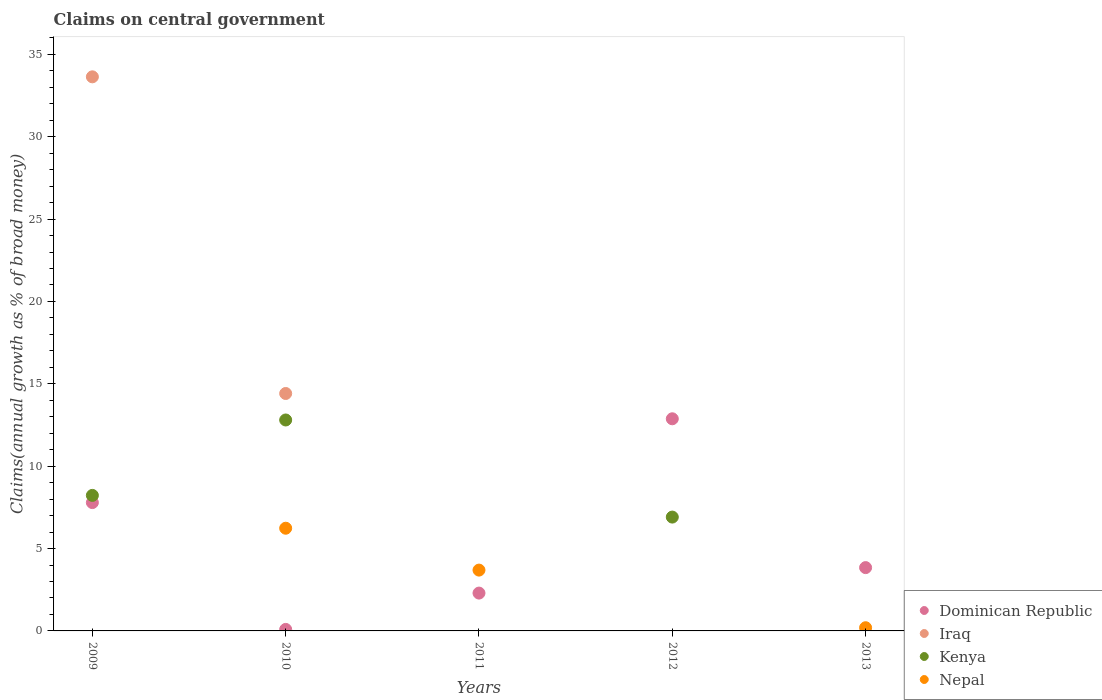Is the number of dotlines equal to the number of legend labels?
Your answer should be very brief. No. What is the percentage of broad money claimed on centeral government in Dominican Republic in 2013?
Provide a short and direct response. 3.84. Across all years, what is the maximum percentage of broad money claimed on centeral government in Iraq?
Provide a succinct answer. 33.64. Across all years, what is the minimum percentage of broad money claimed on centeral government in Nepal?
Provide a succinct answer. 0. In which year was the percentage of broad money claimed on centeral government in Dominican Republic maximum?
Make the answer very short. 2012. What is the total percentage of broad money claimed on centeral government in Nepal in the graph?
Provide a succinct answer. 10.12. What is the difference between the percentage of broad money claimed on centeral government in Iraq in 2009 and that in 2010?
Make the answer very short. 19.22. What is the difference between the percentage of broad money claimed on centeral government in Kenya in 2011 and the percentage of broad money claimed on centeral government in Dominican Republic in 2009?
Your answer should be very brief. -7.79. What is the average percentage of broad money claimed on centeral government in Iraq per year?
Your answer should be very brief. 9.61. In the year 2009, what is the difference between the percentage of broad money claimed on centeral government in Iraq and percentage of broad money claimed on centeral government in Dominican Republic?
Your answer should be very brief. 25.85. What is the ratio of the percentage of broad money claimed on centeral government in Dominican Republic in 2012 to that in 2013?
Give a very brief answer. 3.35. What is the difference between the highest and the second highest percentage of broad money claimed on centeral government in Kenya?
Give a very brief answer. 4.58. What is the difference between the highest and the lowest percentage of broad money claimed on centeral government in Kenya?
Give a very brief answer. 12.81. In how many years, is the percentage of broad money claimed on centeral government in Kenya greater than the average percentage of broad money claimed on centeral government in Kenya taken over all years?
Provide a succinct answer. 3. Is the sum of the percentage of broad money claimed on centeral government in Nepal in 2010 and 2011 greater than the maximum percentage of broad money claimed on centeral government in Kenya across all years?
Provide a succinct answer. No. Does the percentage of broad money claimed on centeral government in Nepal monotonically increase over the years?
Ensure brevity in your answer.  No. Is the percentage of broad money claimed on centeral government in Dominican Republic strictly greater than the percentage of broad money claimed on centeral government in Nepal over the years?
Offer a very short reply. No. What is the difference between two consecutive major ticks on the Y-axis?
Give a very brief answer. 5. Are the values on the major ticks of Y-axis written in scientific E-notation?
Ensure brevity in your answer.  No. Does the graph contain any zero values?
Keep it short and to the point. Yes. Does the graph contain grids?
Keep it short and to the point. No. How are the legend labels stacked?
Your answer should be compact. Vertical. What is the title of the graph?
Offer a terse response. Claims on central government. What is the label or title of the Y-axis?
Provide a succinct answer. Claims(annual growth as % of broad money). What is the Claims(annual growth as % of broad money) in Dominican Republic in 2009?
Make the answer very short. 7.79. What is the Claims(annual growth as % of broad money) in Iraq in 2009?
Ensure brevity in your answer.  33.64. What is the Claims(annual growth as % of broad money) in Kenya in 2009?
Ensure brevity in your answer.  8.23. What is the Claims(annual growth as % of broad money) of Dominican Republic in 2010?
Offer a very short reply. 0.09. What is the Claims(annual growth as % of broad money) in Iraq in 2010?
Keep it short and to the point. 14.41. What is the Claims(annual growth as % of broad money) of Kenya in 2010?
Make the answer very short. 12.81. What is the Claims(annual growth as % of broad money) in Nepal in 2010?
Offer a terse response. 6.23. What is the Claims(annual growth as % of broad money) in Dominican Republic in 2011?
Make the answer very short. 2.3. What is the Claims(annual growth as % of broad money) of Kenya in 2011?
Keep it short and to the point. 0. What is the Claims(annual growth as % of broad money) in Nepal in 2011?
Provide a succinct answer. 3.69. What is the Claims(annual growth as % of broad money) of Dominican Republic in 2012?
Your response must be concise. 12.88. What is the Claims(annual growth as % of broad money) of Iraq in 2012?
Your answer should be compact. 0. What is the Claims(annual growth as % of broad money) of Kenya in 2012?
Offer a terse response. 6.91. What is the Claims(annual growth as % of broad money) of Nepal in 2012?
Your answer should be compact. 0. What is the Claims(annual growth as % of broad money) of Dominican Republic in 2013?
Keep it short and to the point. 3.84. What is the Claims(annual growth as % of broad money) of Iraq in 2013?
Provide a succinct answer. 0. What is the Claims(annual growth as % of broad money) of Kenya in 2013?
Make the answer very short. 0. What is the Claims(annual growth as % of broad money) in Nepal in 2013?
Provide a short and direct response. 0.19. Across all years, what is the maximum Claims(annual growth as % of broad money) in Dominican Republic?
Your response must be concise. 12.88. Across all years, what is the maximum Claims(annual growth as % of broad money) of Iraq?
Ensure brevity in your answer.  33.64. Across all years, what is the maximum Claims(annual growth as % of broad money) in Kenya?
Give a very brief answer. 12.81. Across all years, what is the maximum Claims(annual growth as % of broad money) of Nepal?
Provide a short and direct response. 6.23. Across all years, what is the minimum Claims(annual growth as % of broad money) in Dominican Republic?
Give a very brief answer. 0.09. Across all years, what is the minimum Claims(annual growth as % of broad money) in Iraq?
Make the answer very short. 0. Across all years, what is the minimum Claims(annual growth as % of broad money) in Kenya?
Your answer should be compact. 0. Across all years, what is the minimum Claims(annual growth as % of broad money) in Nepal?
Your answer should be very brief. 0. What is the total Claims(annual growth as % of broad money) in Dominican Republic in the graph?
Your response must be concise. 26.9. What is the total Claims(annual growth as % of broad money) in Iraq in the graph?
Provide a succinct answer. 48.05. What is the total Claims(annual growth as % of broad money) in Kenya in the graph?
Your answer should be very brief. 27.94. What is the total Claims(annual growth as % of broad money) in Nepal in the graph?
Your answer should be compact. 10.12. What is the difference between the Claims(annual growth as % of broad money) in Dominican Republic in 2009 and that in 2010?
Offer a terse response. 7.7. What is the difference between the Claims(annual growth as % of broad money) in Iraq in 2009 and that in 2010?
Give a very brief answer. 19.22. What is the difference between the Claims(annual growth as % of broad money) of Kenya in 2009 and that in 2010?
Your answer should be very brief. -4.58. What is the difference between the Claims(annual growth as % of broad money) of Dominican Republic in 2009 and that in 2011?
Give a very brief answer. 5.49. What is the difference between the Claims(annual growth as % of broad money) in Dominican Republic in 2009 and that in 2012?
Your answer should be compact. -5.09. What is the difference between the Claims(annual growth as % of broad money) of Kenya in 2009 and that in 2012?
Make the answer very short. 1.32. What is the difference between the Claims(annual growth as % of broad money) of Dominican Republic in 2009 and that in 2013?
Offer a terse response. 3.95. What is the difference between the Claims(annual growth as % of broad money) in Dominican Republic in 2010 and that in 2011?
Make the answer very short. -2.21. What is the difference between the Claims(annual growth as % of broad money) in Nepal in 2010 and that in 2011?
Your answer should be compact. 2.54. What is the difference between the Claims(annual growth as % of broad money) in Dominican Republic in 2010 and that in 2012?
Give a very brief answer. -12.79. What is the difference between the Claims(annual growth as % of broad money) in Kenya in 2010 and that in 2012?
Offer a terse response. 5.9. What is the difference between the Claims(annual growth as % of broad money) in Dominican Republic in 2010 and that in 2013?
Your answer should be compact. -3.75. What is the difference between the Claims(annual growth as % of broad money) of Nepal in 2010 and that in 2013?
Your response must be concise. 6.04. What is the difference between the Claims(annual growth as % of broad money) in Dominican Republic in 2011 and that in 2012?
Offer a very short reply. -10.58. What is the difference between the Claims(annual growth as % of broad money) in Dominican Republic in 2011 and that in 2013?
Provide a succinct answer. -1.55. What is the difference between the Claims(annual growth as % of broad money) in Nepal in 2011 and that in 2013?
Ensure brevity in your answer.  3.5. What is the difference between the Claims(annual growth as % of broad money) in Dominican Republic in 2012 and that in 2013?
Offer a very short reply. 9.04. What is the difference between the Claims(annual growth as % of broad money) of Dominican Republic in 2009 and the Claims(annual growth as % of broad money) of Iraq in 2010?
Provide a succinct answer. -6.62. What is the difference between the Claims(annual growth as % of broad money) of Dominican Republic in 2009 and the Claims(annual growth as % of broad money) of Kenya in 2010?
Offer a terse response. -5.01. What is the difference between the Claims(annual growth as % of broad money) in Dominican Republic in 2009 and the Claims(annual growth as % of broad money) in Nepal in 2010?
Your answer should be compact. 1.56. What is the difference between the Claims(annual growth as % of broad money) of Iraq in 2009 and the Claims(annual growth as % of broad money) of Kenya in 2010?
Give a very brief answer. 20.83. What is the difference between the Claims(annual growth as % of broad money) of Iraq in 2009 and the Claims(annual growth as % of broad money) of Nepal in 2010?
Provide a short and direct response. 27.4. What is the difference between the Claims(annual growth as % of broad money) of Kenya in 2009 and the Claims(annual growth as % of broad money) of Nepal in 2010?
Your answer should be very brief. 1.99. What is the difference between the Claims(annual growth as % of broad money) of Dominican Republic in 2009 and the Claims(annual growth as % of broad money) of Nepal in 2011?
Provide a succinct answer. 4.1. What is the difference between the Claims(annual growth as % of broad money) of Iraq in 2009 and the Claims(annual growth as % of broad money) of Nepal in 2011?
Your answer should be very brief. 29.94. What is the difference between the Claims(annual growth as % of broad money) of Kenya in 2009 and the Claims(annual growth as % of broad money) of Nepal in 2011?
Your answer should be compact. 4.53. What is the difference between the Claims(annual growth as % of broad money) of Dominican Republic in 2009 and the Claims(annual growth as % of broad money) of Kenya in 2012?
Make the answer very short. 0.88. What is the difference between the Claims(annual growth as % of broad money) in Iraq in 2009 and the Claims(annual growth as % of broad money) in Kenya in 2012?
Provide a succinct answer. 26.73. What is the difference between the Claims(annual growth as % of broad money) in Dominican Republic in 2009 and the Claims(annual growth as % of broad money) in Nepal in 2013?
Provide a short and direct response. 7.6. What is the difference between the Claims(annual growth as % of broad money) in Iraq in 2009 and the Claims(annual growth as % of broad money) in Nepal in 2013?
Your answer should be very brief. 33.44. What is the difference between the Claims(annual growth as % of broad money) of Kenya in 2009 and the Claims(annual growth as % of broad money) of Nepal in 2013?
Your response must be concise. 8.03. What is the difference between the Claims(annual growth as % of broad money) in Dominican Republic in 2010 and the Claims(annual growth as % of broad money) in Nepal in 2011?
Your answer should be compact. -3.6. What is the difference between the Claims(annual growth as % of broad money) of Iraq in 2010 and the Claims(annual growth as % of broad money) of Nepal in 2011?
Your response must be concise. 10.72. What is the difference between the Claims(annual growth as % of broad money) of Kenya in 2010 and the Claims(annual growth as % of broad money) of Nepal in 2011?
Ensure brevity in your answer.  9.11. What is the difference between the Claims(annual growth as % of broad money) in Dominican Republic in 2010 and the Claims(annual growth as % of broad money) in Kenya in 2012?
Ensure brevity in your answer.  -6.82. What is the difference between the Claims(annual growth as % of broad money) of Iraq in 2010 and the Claims(annual growth as % of broad money) of Kenya in 2012?
Your response must be concise. 7.5. What is the difference between the Claims(annual growth as % of broad money) in Dominican Republic in 2010 and the Claims(annual growth as % of broad money) in Nepal in 2013?
Offer a very short reply. -0.1. What is the difference between the Claims(annual growth as % of broad money) of Iraq in 2010 and the Claims(annual growth as % of broad money) of Nepal in 2013?
Offer a terse response. 14.22. What is the difference between the Claims(annual growth as % of broad money) in Kenya in 2010 and the Claims(annual growth as % of broad money) in Nepal in 2013?
Provide a succinct answer. 12.61. What is the difference between the Claims(annual growth as % of broad money) in Dominican Republic in 2011 and the Claims(annual growth as % of broad money) in Kenya in 2012?
Provide a succinct answer. -4.61. What is the difference between the Claims(annual growth as % of broad money) of Dominican Republic in 2011 and the Claims(annual growth as % of broad money) of Nepal in 2013?
Make the answer very short. 2.1. What is the difference between the Claims(annual growth as % of broad money) in Dominican Republic in 2012 and the Claims(annual growth as % of broad money) in Nepal in 2013?
Your answer should be very brief. 12.68. What is the difference between the Claims(annual growth as % of broad money) in Kenya in 2012 and the Claims(annual growth as % of broad money) in Nepal in 2013?
Provide a short and direct response. 6.72. What is the average Claims(annual growth as % of broad money) of Dominican Republic per year?
Your response must be concise. 5.38. What is the average Claims(annual growth as % of broad money) of Iraq per year?
Offer a terse response. 9.61. What is the average Claims(annual growth as % of broad money) in Kenya per year?
Provide a succinct answer. 5.59. What is the average Claims(annual growth as % of broad money) in Nepal per year?
Your response must be concise. 2.02. In the year 2009, what is the difference between the Claims(annual growth as % of broad money) in Dominican Republic and Claims(annual growth as % of broad money) in Iraq?
Your response must be concise. -25.85. In the year 2009, what is the difference between the Claims(annual growth as % of broad money) of Dominican Republic and Claims(annual growth as % of broad money) of Kenya?
Your answer should be compact. -0.44. In the year 2009, what is the difference between the Claims(annual growth as % of broad money) of Iraq and Claims(annual growth as % of broad money) of Kenya?
Provide a short and direct response. 25.41. In the year 2010, what is the difference between the Claims(annual growth as % of broad money) of Dominican Republic and Claims(annual growth as % of broad money) of Iraq?
Provide a short and direct response. -14.32. In the year 2010, what is the difference between the Claims(annual growth as % of broad money) of Dominican Republic and Claims(annual growth as % of broad money) of Kenya?
Give a very brief answer. -12.71. In the year 2010, what is the difference between the Claims(annual growth as % of broad money) of Dominican Republic and Claims(annual growth as % of broad money) of Nepal?
Offer a very short reply. -6.14. In the year 2010, what is the difference between the Claims(annual growth as % of broad money) in Iraq and Claims(annual growth as % of broad money) in Kenya?
Your answer should be compact. 1.61. In the year 2010, what is the difference between the Claims(annual growth as % of broad money) in Iraq and Claims(annual growth as % of broad money) in Nepal?
Offer a very short reply. 8.18. In the year 2010, what is the difference between the Claims(annual growth as % of broad money) in Kenya and Claims(annual growth as % of broad money) in Nepal?
Your response must be concise. 6.57. In the year 2011, what is the difference between the Claims(annual growth as % of broad money) in Dominican Republic and Claims(annual growth as % of broad money) in Nepal?
Give a very brief answer. -1.4. In the year 2012, what is the difference between the Claims(annual growth as % of broad money) in Dominican Republic and Claims(annual growth as % of broad money) in Kenya?
Your answer should be compact. 5.97. In the year 2013, what is the difference between the Claims(annual growth as % of broad money) of Dominican Republic and Claims(annual growth as % of broad money) of Nepal?
Make the answer very short. 3.65. What is the ratio of the Claims(annual growth as % of broad money) in Dominican Republic in 2009 to that in 2010?
Make the answer very short. 85.27. What is the ratio of the Claims(annual growth as % of broad money) of Iraq in 2009 to that in 2010?
Provide a succinct answer. 2.33. What is the ratio of the Claims(annual growth as % of broad money) of Kenya in 2009 to that in 2010?
Offer a very short reply. 0.64. What is the ratio of the Claims(annual growth as % of broad money) of Dominican Republic in 2009 to that in 2011?
Provide a succinct answer. 3.39. What is the ratio of the Claims(annual growth as % of broad money) of Dominican Republic in 2009 to that in 2012?
Give a very brief answer. 0.6. What is the ratio of the Claims(annual growth as % of broad money) in Kenya in 2009 to that in 2012?
Ensure brevity in your answer.  1.19. What is the ratio of the Claims(annual growth as % of broad money) in Dominican Republic in 2009 to that in 2013?
Provide a short and direct response. 2.03. What is the ratio of the Claims(annual growth as % of broad money) of Dominican Republic in 2010 to that in 2011?
Give a very brief answer. 0.04. What is the ratio of the Claims(annual growth as % of broad money) in Nepal in 2010 to that in 2011?
Ensure brevity in your answer.  1.69. What is the ratio of the Claims(annual growth as % of broad money) of Dominican Republic in 2010 to that in 2012?
Keep it short and to the point. 0.01. What is the ratio of the Claims(annual growth as % of broad money) of Kenya in 2010 to that in 2012?
Your response must be concise. 1.85. What is the ratio of the Claims(annual growth as % of broad money) in Dominican Republic in 2010 to that in 2013?
Provide a short and direct response. 0.02. What is the ratio of the Claims(annual growth as % of broad money) in Nepal in 2010 to that in 2013?
Make the answer very short. 32.09. What is the ratio of the Claims(annual growth as % of broad money) of Dominican Republic in 2011 to that in 2012?
Give a very brief answer. 0.18. What is the ratio of the Claims(annual growth as % of broad money) in Dominican Republic in 2011 to that in 2013?
Provide a succinct answer. 0.6. What is the ratio of the Claims(annual growth as % of broad money) in Nepal in 2011 to that in 2013?
Offer a terse response. 19. What is the ratio of the Claims(annual growth as % of broad money) of Dominican Republic in 2012 to that in 2013?
Provide a short and direct response. 3.35. What is the difference between the highest and the second highest Claims(annual growth as % of broad money) of Dominican Republic?
Give a very brief answer. 5.09. What is the difference between the highest and the second highest Claims(annual growth as % of broad money) in Kenya?
Keep it short and to the point. 4.58. What is the difference between the highest and the second highest Claims(annual growth as % of broad money) of Nepal?
Offer a terse response. 2.54. What is the difference between the highest and the lowest Claims(annual growth as % of broad money) in Dominican Republic?
Provide a succinct answer. 12.79. What is the difference between the highest and the lowest Claims(annual growth as % of broad money) of Iraq?
Provide a short and direct response. 33.64. What is the difference between the highest and the lowest Claims(annual growth as % of broad money) of Kenya?
Your response must be concise. 12.81. What is the difference between the highest and the lowest Claims(annual growth as % of broad money) in Nepal?
Ensure brevity in your answer.  6.23. 